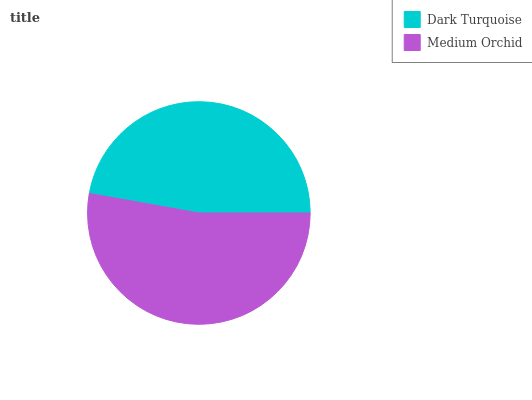Is Dark Turquoise the minimum?
Answer yes or no. Yes. Is Medium Orchid the maximum?
Answer yes or no. Yes. Is Medium Orchid the minimum?
Answer yes or no. No. Is Medium Orchid greater than Dark Turquoise?
Answer yes or no. Yes. Is Dark Turquoise less than Medium Orchid?
Answer yes or no. Yes. Is Dark Turquoise greater than Medium Orchid?
Answer yes or no. No. Is Medium Orchid less than Dark Turquoise?
Answer yes or no. No. Is Medium Orchid the high median?
Answer yes or no. Yes. Is Dark Turquoise the low median?
Answer yes or no. Yes. Is Dark Turquoise the high median?
Answer yes or no. No. Is Medium Orchid the low median?
Answer yes or no. No. 